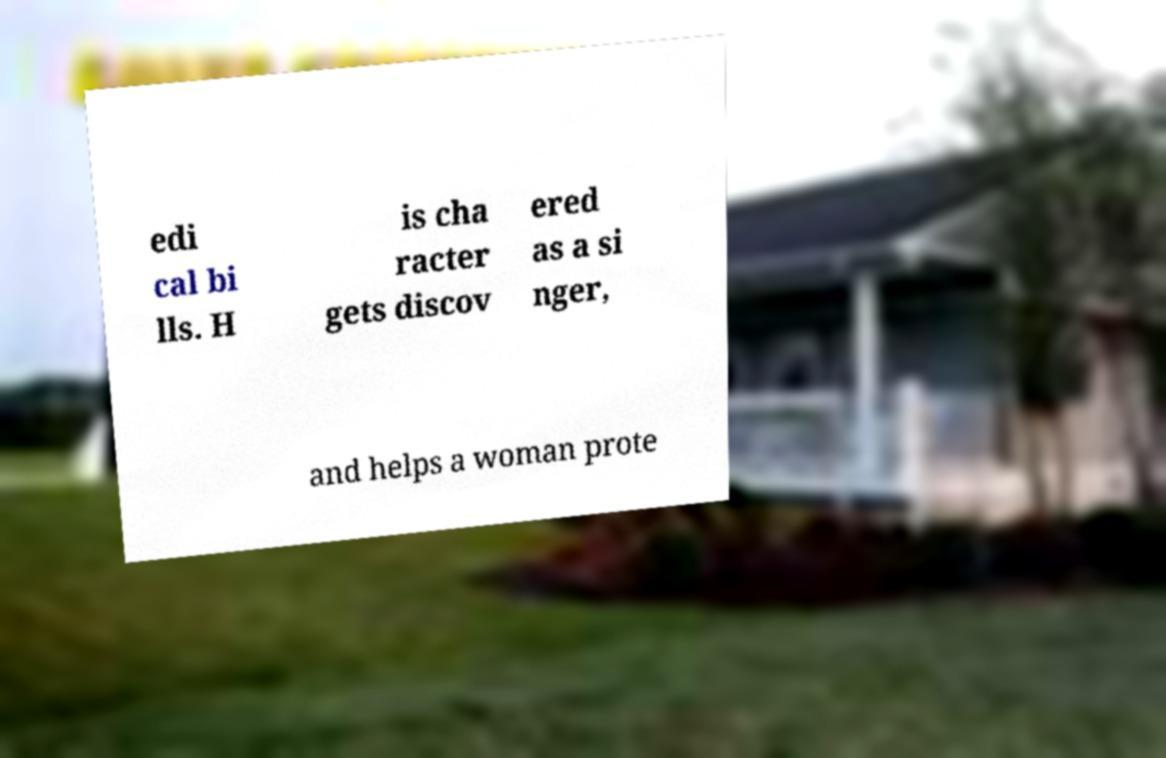There's text embedded in this image that I need extracted. Can you transcribe it verbatim? edi cal bi lls. H is cha racter gets discov ered as a si nger, and helps a woman prote 